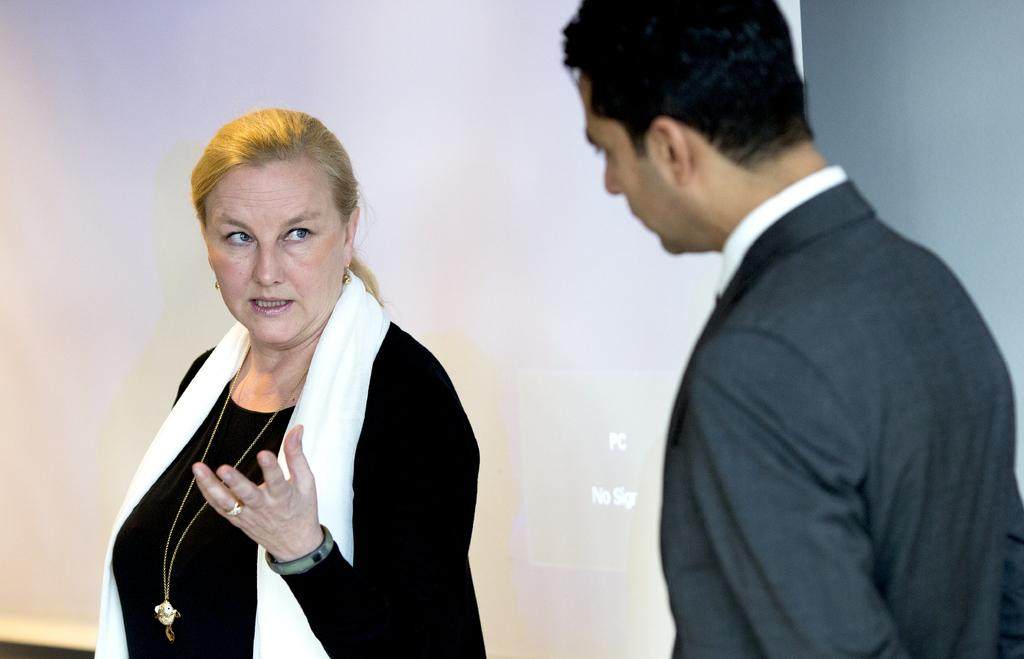Who is present in the image? There is a woman and a person in the image. What is the woman wearing in the image? The woman is wearing a scarf in the image. What is the person wearing in the image? The person is wearing a blazer in the image. What can be seen on the wall in the background of the image? There is a screen attached to the wall in the background of the image. What type of ship can be seen sailing in the background of the image? There is no ship visible in the image; it only features a woman, a person, and a screen on the wall. How many eyes does the person have in the image? The number of eyes cannot be determined from the image, as it only shows the person's blazer and not their face. 